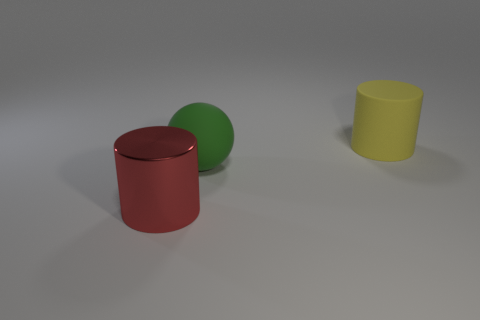Add 2 small green balls. How many objects exist? 5 Subtract all red objects. Subtract all big yellow matte things. How many objects are left? 1 Add 2 cylinders. How many cylinders are left? 4 Add 2 big yellow cubes. How many big yellow cubes exist? 2 Subtract 0 red cubes. How many objects are left? 3 Subtract all cylinders. How many objects are left? 1 Subtract 1 spheres. How many spheres are left? 0 Subtract all yellow balls. Subtract all yellow blocks. How many balls are left? 1 Subtract all green balls. How many red cylinders are left? 1 